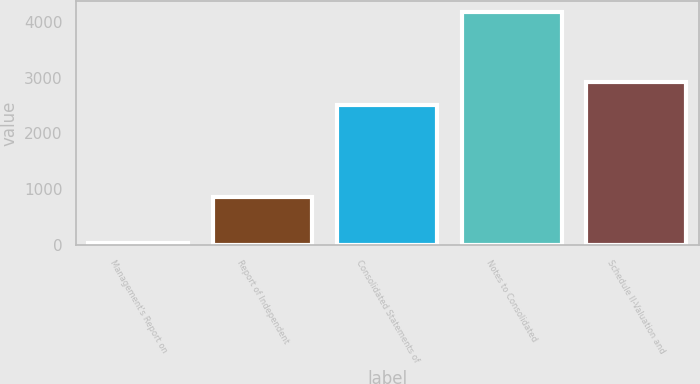Convert chart. <chart><loc_0><loc_0><loc_500><loc_500><bar_chart><fcel>Management's Report on<fcel>Report of Independent<fcel>Consolidated Statements of<fcel>Notes to Consolidated<fcel>Schedule II-Valuation and<nl><fcel>34<fcel>860.8<fcel>2514.4<fcel>4168<fcel>2927.8<nl></chart> 